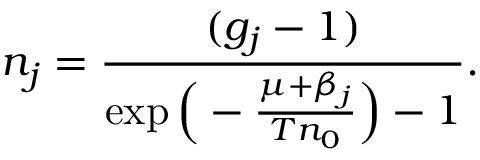<formula> <loc_0><loc_0><loc_500><loc_500>n _ { j } = \frac { ( g _ { j } - 1 ) } { \exp { \left ( - \frac { \mu + \beta _ { j } } { T n _ { 0 } } \right ) } - 1 } .</formula> 